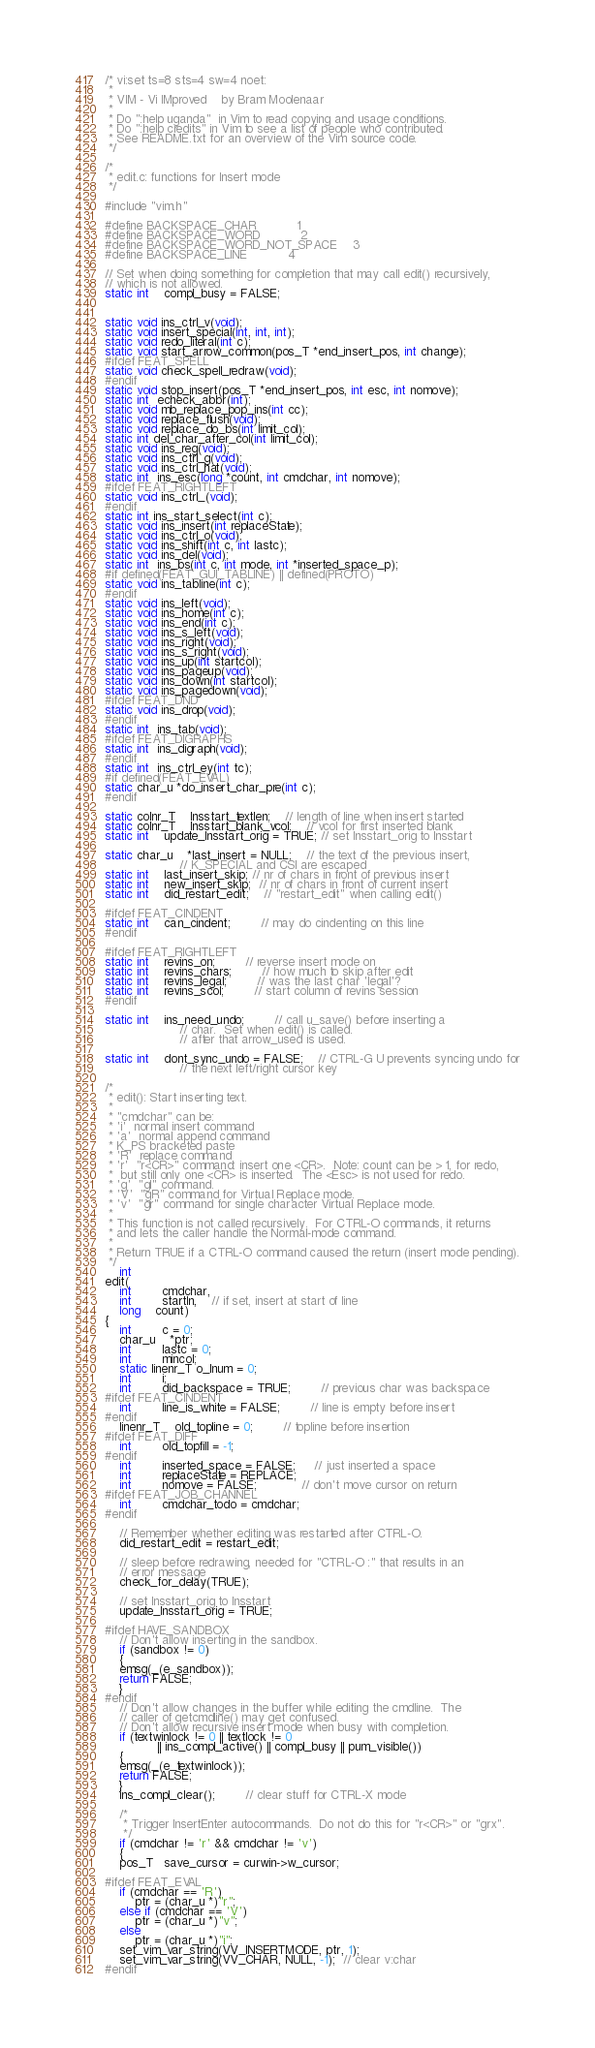Convert code to text. <code><loc_0><loc_0><loc_500><loc_500><_C_>/* vi:set ts=8 sts=4 sw=4 noet:
 *
 * VIM - Vi IMproved	by Bram Moolenaar
 *
 * Do ":help uganda"  in Vim to read copying and usage conditions.
 * Do ":help credits" in Vim to see a list of people who contributed.
 * See README.txt for an overview of the Vim source code.
 */

/*
 * edit.c: functions for Insert mode
 */

#include "vim.h"

#define BACKSPACE_CHAR		    1
#define BACKSPACE_WORD		    2
#define BACKSPACE_WORD_NOT_SPACE    3
#define BACKSPACE_LINE		    4

// Set when doing something for completion that may call edit() recursively,
// which is not allowed.
static int	compl_busy = FALSE;


static void ins_ctrl_v(void);
static void insert_special(int, int, int);
static void redo_literal(int c);
static void start_arrow_common(pos_T *end_insert_pos, int change);
#ifdef FEAT_SPELL
static void check_spell_redraw(void);
#endif
static void stop_insert(pos_T *end_insert_pos, int esc, int nomove);
static int  echeck_abbr(int);
static void mb_replace_pop_ins(int cc);
static void replace_flush(void);
static void replace_do_bs(int limit_col);
static int del_char_after_col(int limit_col);
static void ins_reg(void);
static void ins_ctrl_g(void);
static void ins_ctrl_hat(void);
static int  ins_esc(long *count, int cmdchar, int nomove);
#ifdef FEAT_RIGHTLEFT
static void ins_ctrl_(void);
#endif
static int ins_start_select(int c);
static void ins_insert(int replaceState);
static void ins_ctrl_o(void);
static void ins_shift(int c, int lastc);
static void ins_del(void);
static int  ins_bs(int c, int mode, int *inserted_space_p);
#if defined(FEAT_GUI_TABLINE) || defined(PROTO)
static void ins_tabline(int c);
#endif
static void ins_left(void);
static void ins_home(int c);
static void ins_end(int c);
static void ins_s_left(void);
static void ins_right(void);
static void ins_s_right(void);
static void ins_up(int startcol);
static void ins_pageup(void);
static void ins_down(int startcol);
static void ins_pagedown(void);
#ifdef FEAT_DND
static void ins_drop(void);
#endif
static int  ins_tab(void);
#ifdef FEAT_DIGRAPHS
static int  ins_digraph(void);
#endif
static int  ins_ctrl_ey(int tc);
#if defined(FEAT_EVAL)
static char_u *do_insert_char_pre(int c);
#endif

static colnr_T	Insstart_textlen;	// length of line when insert started
static colnr_T	Insstart_blank_vcol;	// vcol for first inserted blank
static int	update_Insstart_orig = TRUE; // set Insstart_orig to Insstart

static char_u	*last_insert = NULL;	// the text of the previous insert,
					// K_SPECIAL and CSI are escaped
static int	last_insert_skip; // nr of chars in front of previous insert
static int	new_insert_skip;  // nr of chars in front of current insert
static int	did_restart_edit;	// "restart_edit" when calling edit()

#ifdef FEAT_CINDENT
static int	can_cindent;		// may do cindenting on this line
#endif

#ifdef FEAT_RIGHTLEFT
static int	revins_on;		// reverse insert mode on
static int	revins_chars;		// how much to skip after edit
static int	revins_legal;		// was the last char 'legal'?
static int	revins_scol;		// start column of revins session
#endif

static int	ins_need_undo;		// call u_save() before inserting a
					// char.  Set when edit() is called.
					// after that arrow_used is used.

static int	dont_sync_undo = FALSE;	// CTRL-G U prevents syncing undo for
					// the next left/right cursor key

/*
 * edit(): Start inserting text.
 *
 * "cmdchar" can be:
 * 'i'	normal insert command
 * 'a'	normal append command
 * K_PS bracketed paste
 * 'R'	replace command
 * 'r'	"r<CR>" command: insert one <CR>.  Note: count can be > 1, for redo,
 *	but still only one <CR> is inserted.  The <Esc> is not used for redo.
 * 'g'	"gI" command.
 * 'V'	"gR" command for Virtual Replace mode.
 * 'v'	"gr" command for single character Virtual Replace mode.
 *
 * This function is not called recursively.  For CTRL-O commands, it returns
 * and lets the caller handle the Normal-mode command.
 *
 * Return TRUE if a CTRL-O command caused the return (insert mode pending).
 */
    int
edit(
    int		cmdchar,
    int		startln,	// if set, insert at start of line
    long	count)
{
    int		c = 0;
    char_u	*ptr;
    int		lastc = 0;
    int		mincol;
    static linenr_T o_lnum = 0;
    int		i;
    int		did_backspace = TRUE;	    // previous char was backspace
#ifdef FEAT_CINDENT
    int		line_is_white = FALSE;	    // line is empty before insert
#endif
    linenr_T	old_topline = 0;	    // topline before insertion
#ifdef FEAT_DIFF
    int		old_topfill = -1;
#endif
    int		inserted_space = FALSE;     // just inserted a space
    int		replaceState = REPLACE;
    int		nomove = FALSE;		    // don't move cursor on return
#ifdef FEAT_JOB_CHANNEL
    int		cmdchar_todo = cmdchar;
#endif

    // Remember whether editing was restarted after CTRL-O.
    did_restart_edit = restart_edit;

    // sleep before redrawing, needed for "CTRL-O :" that results in an
    // error message
    check_for_delay(TRUE);

    // set Insstart_orig to Insstart
    update_Insstart_orig = TRUE;

#ifdef HAVE_SANDBOX
    // Don't allow inserting in the sandbox.
    if (sandbox != 0)
    {
	emsg(_(e_sandbox));
	return FALSE;
    }
#endif
    // Don't allow changes in the buffer while editing the cmdline.  The
    // caller of getcmdline() may get confused.
    // Don't allow recursive insert mode when busy with completion.
    if (textwinlock != 0 || textlock != 0
			  || ins_compl_active() || compl_busy || pum_visible())
    {
	emsg(_(e_textwinlock));
	return FALSE;
    }
    ins_compl_clear();	    // clear stuff for CTRL-X mode

    /*
     * Trigger InsertEnter autocommands.  Do not do this for "r<CR>" or "grx".
     */
    if (cmdchar != 'r' && cmdchar != 'v')
    {
	pos_T   save_cursor = curwin->w_cursor;

#ifdef FEAT_EVAL
	if (cmdchar == 'R')
	    ptr = (char_u *)"r";
	else if (cmdchar == 'V')
	    ptr = (char_u *)"v";
	else
	    ptr = (char_u *)"i";
	set_vim_var_string(VV_INSERTMODE, ptr, 1);
	set_vim_var_string(VV_CHAR, NULL, -1);  // clear v:char
#endif</code> 